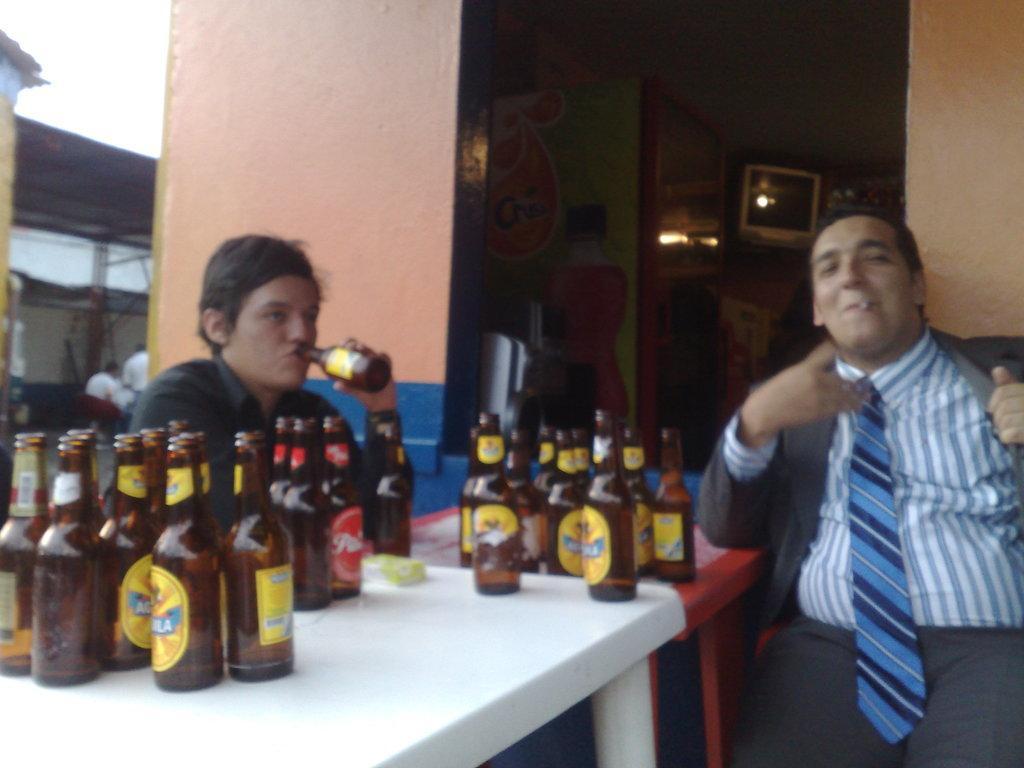In one or two sentences, can you explain what this image depicts? In this picture there is a boy who is sitting at the left side of the image and there are cool drinks in front of him on a table and there is another boy at the right side of the image who is smoking and there is a refrigerator at the left side of the image. 